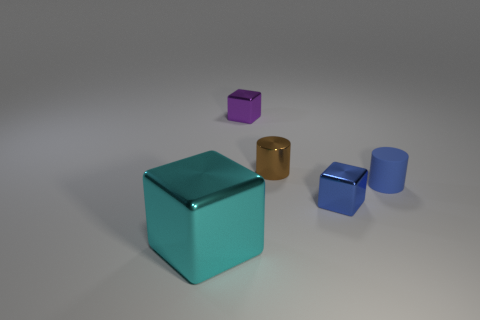The tiny brown metal thing that is in front of the purple metal cube on the left side of the cube that is to the right of the small brown metal thing is what shape?
Offer a terse response. Cylinder. Is the size of the shiny thing behind the small brown metal cylinder the same as the shiny cube right of the purple thing?
Your answer should be very brief. Yes. How many tiny blue blocks are made of the same material as the big cube?
Your response must be concise. 1. There is a blue object that is left of the small cylinder that is to the right of the blue cube; what number of tiny rubber cylinders are right of it?
Give a very brief answer. 1. Is the shape of the cyan object the same as the tiny blue metallic object?
Provide a short and direct response. Yes. Are there any other small red rubber objects of the same shape as the small rubber thing?
Keep it short and to the point. No. The brown object that is the same size as the blue rubber object is what shape?
Ensure brevity in your answer.  Cylinder. There is a block that is behind the tiny cube that is in front of the tiny block that is behind the tiny blue cylinder; what is its material?
Your response must be concise. Metal. Do the blue rubber thing and the purple metallic block have the same size?
Your response must be concise. Yes. What is the blue cylinder made of?
Provide a succinct answer. Rubber. 